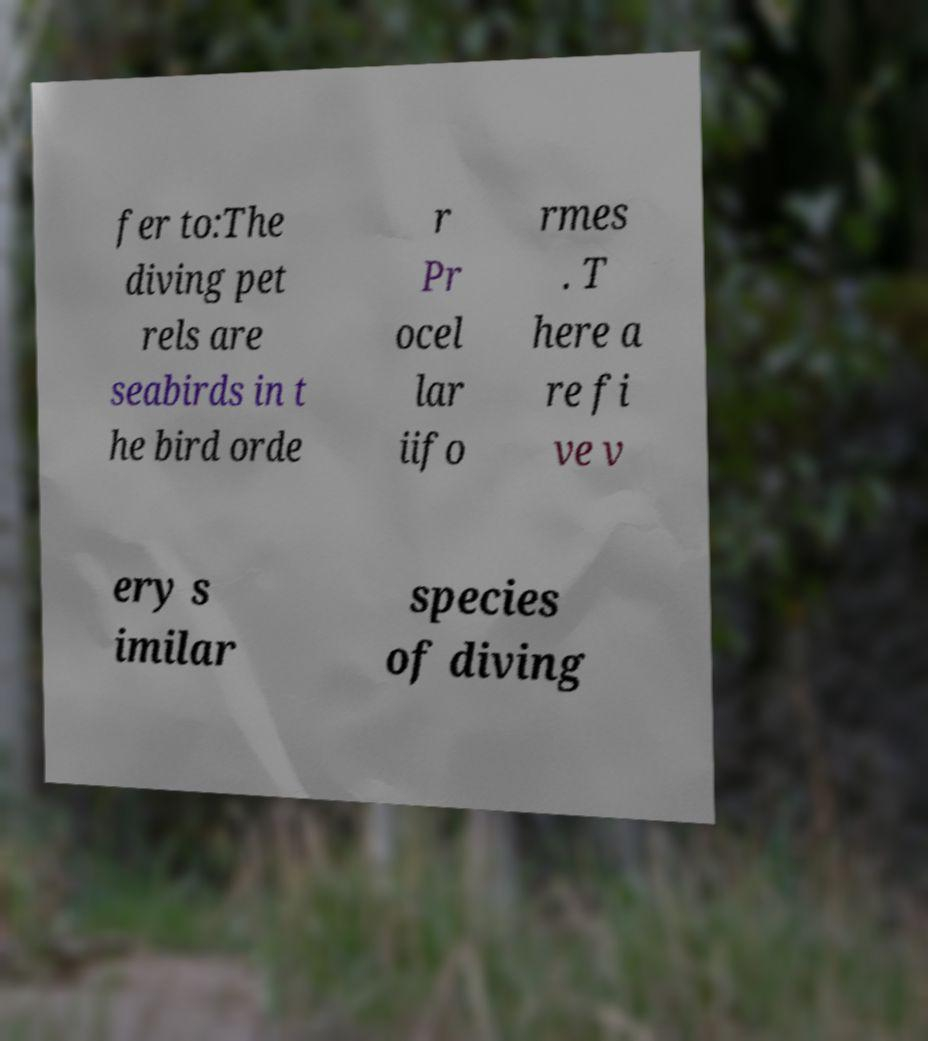Can you read and provide the text displayed in the image?This photo seems to have some interesting text. Can you extract and type it out for me? fer to:The diving pet rels are seabirds in t he bird orde r Pr ocel lar iifo rmes . T here a re fi ve v ery s imilar species of diving 